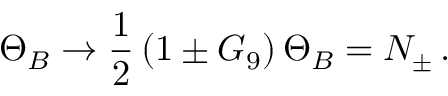<formula> <loc_0><loc_0><loc_500><loc_500>\Theta _ { B } \to \frac { 1 } { 2 } \left ( 1 \pm G _ { 9 } \right ) \Theta _ { B } = N _ { \pm } \, .</formula> 